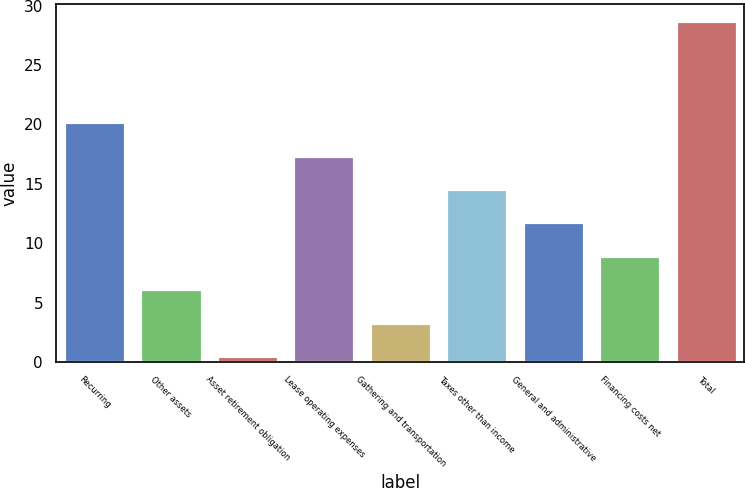Convert chart. <chart><loc_0><loc_0><loc_500><loc_500><bar_chart><fcel>Recurring<fcel>Other assets<fcel>Asset retirement obligation<fcel>Lease operating expenses<fcel>Gathering and transportation<fcel>Taxes other than income<fcel>General and administrative<fcel>Financing costs net<fcel>Total<nl><fcel>20.2<fcel>6.1<fcel>0.46<fcel>17.38<fcel>3.28<fcel>14.56<fcel>11.74<fcel>8.92<fcel>28.68<nl></chart> 